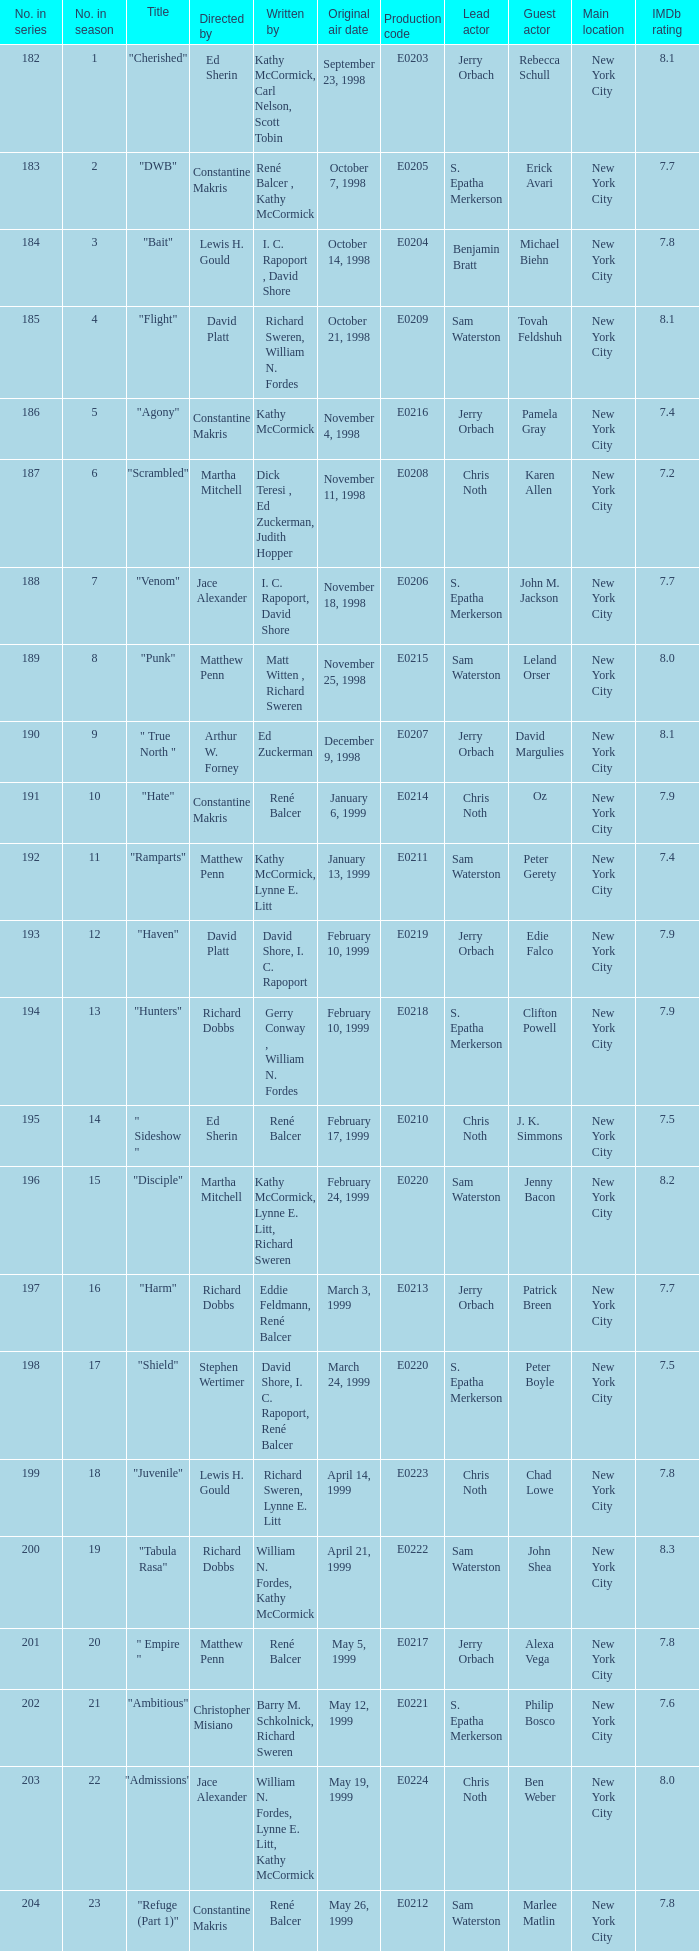What is the title of the episode with the original air date October 21, 1998? "Flight". 